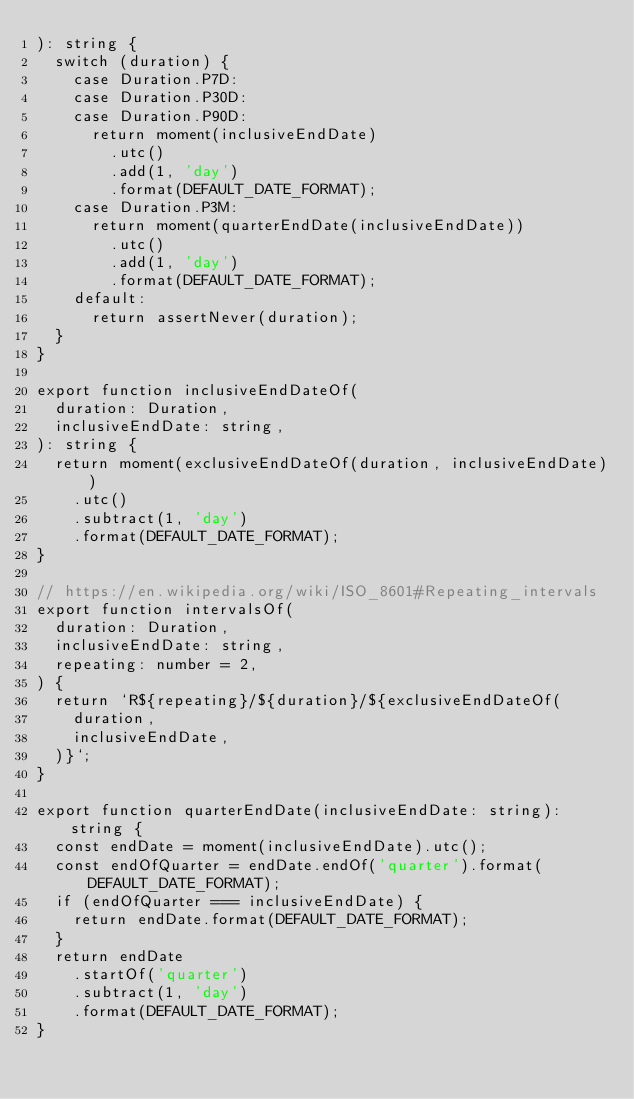Convert code to text. <code><loc_0><loc_0><loc_500><loc_500><_TypeScript_>): string {
  switch (duration) {
    case Duration.P7D:
    case Duration.P30D:
    case Duration.P90D:
      return moment(inclusiveEndDate)
        .utc()
        .add(1, 'day')
        .format(DEFAULT_DATE_FORMAT);
    case Duration.P3M:
      return moment(quarterEndDate(inclusiveEndDate))
        .utc()
        .add(1, 'day')
        .format(DEFAULT_DATE_FORMAT);
    default:
      return assertNever(duration);
  }
}

export function inclusiveEndDateOf(
  duration: Duration,
  inclusiveEndDate: string,
): string {
  return moment(exclusiveEndDateOf(duration, inclusiveEndDate))
    .utc()
    .subtract(1, 'day')
    .format(DEFAULT_DATE_FORMAT);
}

// https://en.wikipedia.org/wiki/ISO_8601#Repeating_intervals
export function intervalsOf(
  duration: Duration,
  inclusiveEndDate: string,
  repeating: number = 2,
) {
  return `R${repeating}/${duration}/${exclusiveEndDateOf(
    duration,
    inclusiveEndDate,
  )}`;
}

export function quarterEndDate(inclusiveEndDate: string): string {
  const endDate = moment(inclusiveEndDate).utc();
  const endOfQuarter = endDate.endOf('quarter').format(DEFAULT_DATE_FORMAT);
  if (endOfQuarter === inclusiveEndDate) {
    return endDate.format(DEFAULT_DATE_FORMAT);
  }
  return endDate
    .startOf('quarter')
    .subtract(1, 'day')
    .format(DEFAULT_DATE_FORMAT);
}
</code> 